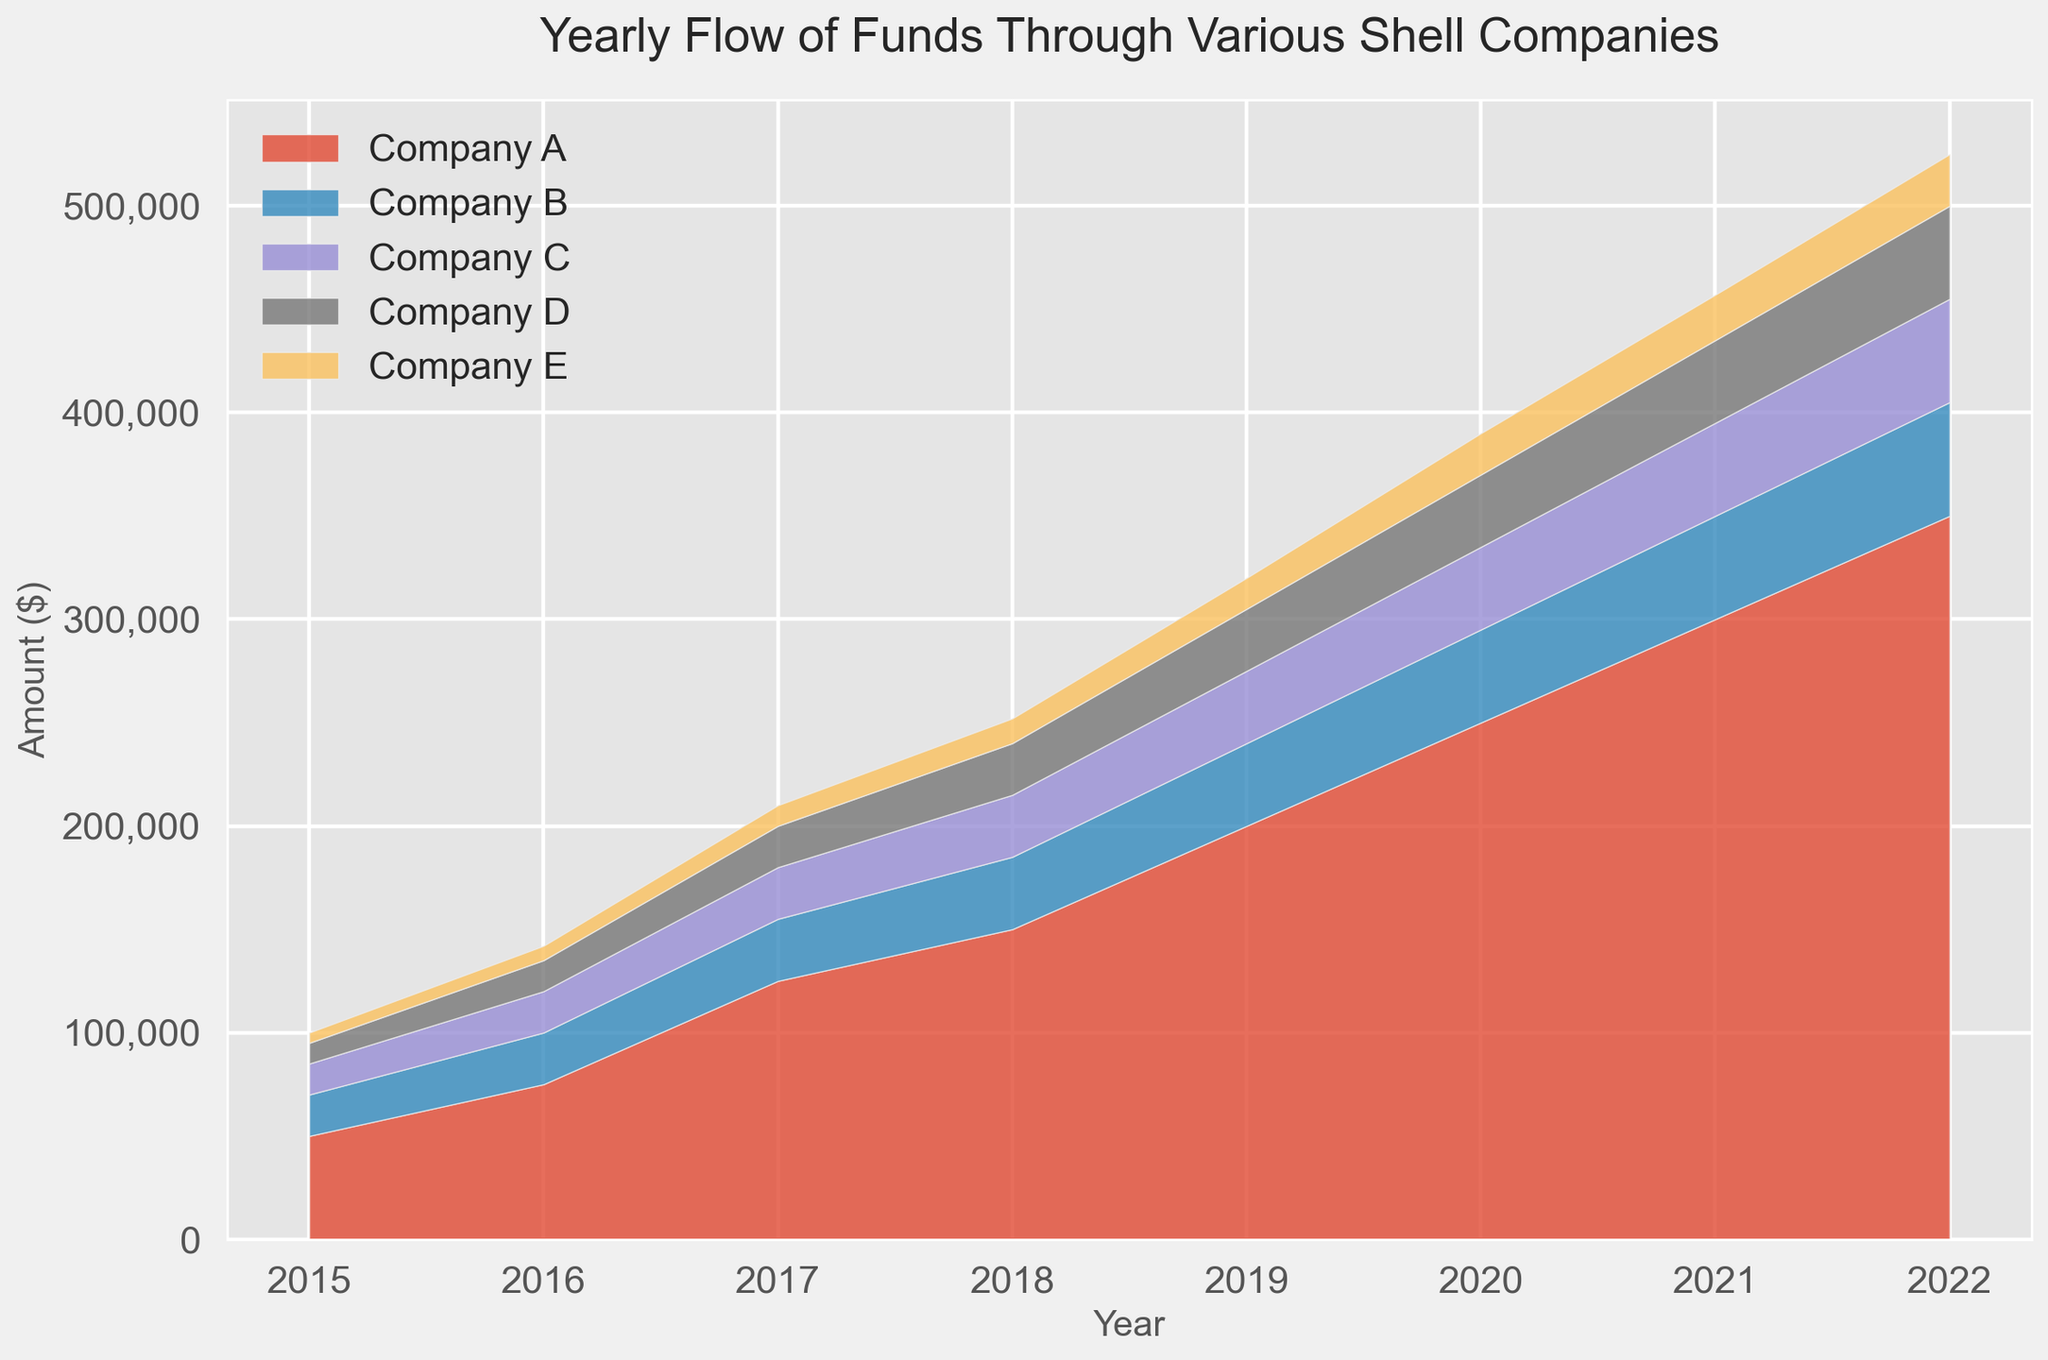Which company shows the largest increase in fund flow from 2015 to 2022? The largest increase can be determined by subtracting the fund flow value in 2015 from the value in 2022 for each company. Company A: 350,000 - 50,000 = 300,000, Company B: 55,000 - 20,000 = 35,000, Company C: 50,000 - 15,000 = 35,000, Company D: 45,000 - 10,000 = 35,000, Company E: 25,000 - 5,000 = 20,000. Company A shows the largest increase.
Answer: Company A Which company had the lowest flow of funds in 2017? Checking the figure for the year 2017, the values for each company are shown. The lowest value among Company A, B, C, D, and E in 2017 are: Company A: 125,000, Company B: 30,000, Company C: 25,000, Company D: 20,000, Company E: 10,000. Company E has the lowest flow of funds in 2017.
Answer: Company E By how much did the total fund flow for all companies combined increase from 2015 to 2022? Add the values for all companies for 2015 and 2022 separately and then subtract to find the increase. Total for 2015: 50,000 + 20,000 + 15,000 + 10,000 + 5,000 = 100,000. Total for 2022: 350,000 + 55,000 + 50,000 + 45,000 + 25,000 = 525,000. The increase is 525,000 - 100,000 = 425,000.
Answer: 425,000 Which year shows the highest combined fund flow across all companies, and what is the amount? Sum the values for each year and identify the maximum. 2015: 100,000; 2016: 145,000; 2017: 210,000; 2018: 252,000; 2019: 320,000; 2020: 370,000; 2021: 417,000; 2022: 525,000. The highest combined fund flow is in 2022 with 525,000.
Answer: 2022 with 525,000 In which year did Company B have the greatest year-over-year increase in fund flow? Calculate the year-over-year increase for Company B. 2016-2015: 25,000 - 20,000 = 5,000; 2017-2016: 30,000 - 25,000 = 5,000; 2018-2017: 35,000 - 30,000 = 5,000; 2019-2018: 40,000 - 35,000 = 5,000; 2020-2019: 45,000 - 40,000 = 5,000; 2021-2020: 50,000 - 45,000 = 5,000; 2022-2021: 55,000 - 50,000 = 5,000. The year-over-year increase is consistent, but the first increase occurred between 2015 and 2016.
Answer: 2016 How does the fund flow trend of Company B from 2015 to 2022 compare with that of Company D? Analyze the trend lines for both companies from 2015 to 2022. Both Company's fund flows increase every year. Company B's trend has a steady linear increase, while Company D shows a similar linear upward trend but starts from a lower baseline and ends at a lower value than Company B in 2022.
Answer: Both increase steadily, but Company B starts higher and ends higher What is the percentage increase in the flow of funds for Company C from 2015 to 2022? Calculate the percentage change using the formula: ((final value - initial value) / initial value) * 100. For Company C: ((50,000 - 15,000) / 15,000) * 100 = 233.33%.
Answer: 233.33% Which company had the highest flow of funds in 2021? Checking the values for 2021, we see: Company A: 300,000, Company B: 50,000, Company C: 45,000, Company D: 40,000, Company E: 22,000. Company A has the highest flow in 2021.
Answer: Company A 